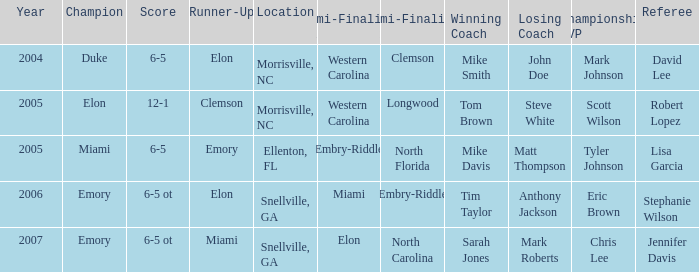When Embry-Riddle made it to the first semi finalist slot, list all the runners up. Emory. 